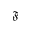<formula> <loc_0><loc_0><loc_500><loc_500>\mathfrak { F }</formula> 